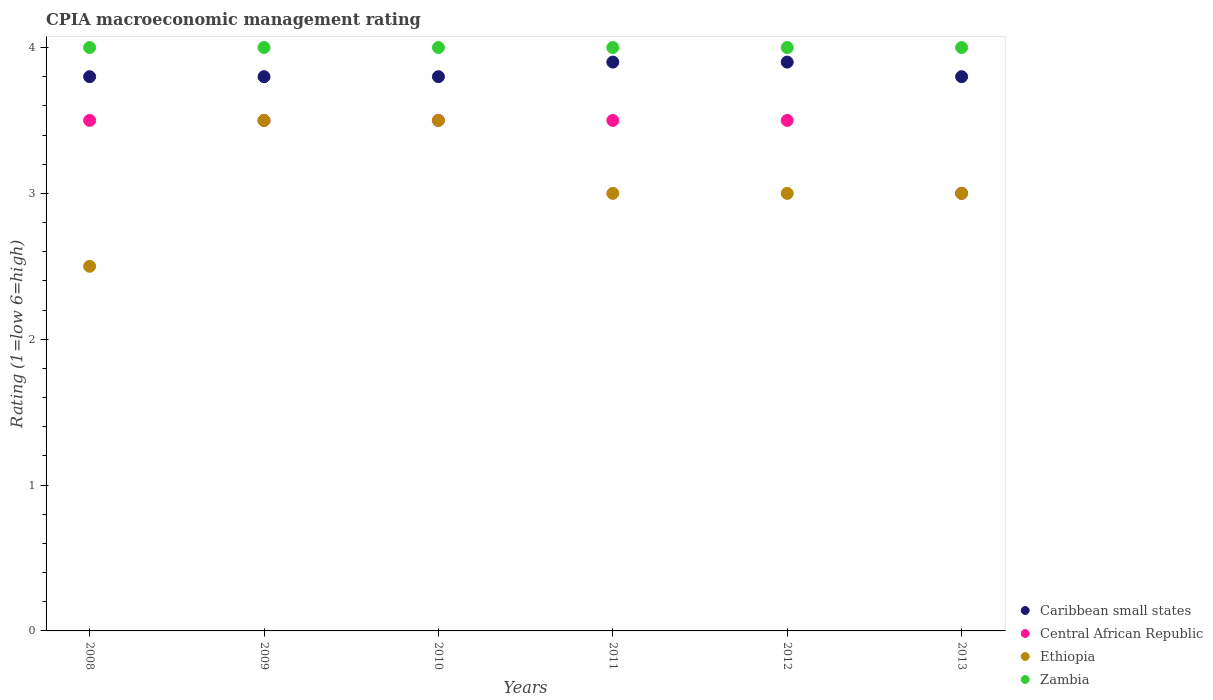How many different coloured dotlines are there?
Your answer should be very brief. 4. What is the CPIA rating in Ethiopia in 2011?
Your answer should be very brief. 3. Across all years, what is the maximum CPIA rating in Zambia?
Your answer should be very brief. 4. In which year was the CPIA rating in Caribbean small states minimum?
Your answer should be very brief. 2008. What is the total CPIA rating in Ethiopia in the graph?
Give a very brief answer. 18.5. What is the difference between the CPIA rating in Ethiopia in 2009 and that in 2010?
Make the answer very short. 0. What is the difference between the CPIA rating in Zambia in 2010 and the CPIA rating in Central African Republic in 2008?
Offer a very short reply. 0.5. What is the average CPIA rating in Central African Republic per year?
Offer a very short reply. 3.42. In the year 2013, what is the difference between the CPIA rating in Zambia and CPIA rating in Caribbean small states?
Offer a very short reply. 0.2. In how many years, is the CPIA rating in Ethiopia greater than 0.4?
Your response must be concise. 6. What is the ratio of the CPIA rating in Caribbean small states in 2011 to that in 2013?
Offer a very short reply. 1.03. Is the CPIA rating in Caribbean small states in 2012 less than that in 2013?
Your response must be concise. No. What is the difference between the highest and the second highest CPIA rating in Ethiopia?
Give a very brief answer. 0. What is the difference between the highest and the lowest CPIA rating in Central African Republic?
Provide a succinct answer. 0.5. In how many years, is the CPIA rating in Central African Republic greater than the average CPIA rating in Central African Republic taken over all years?
Ensure brevity in your answer.  5. Is it the case that in every year, the sum of the CPIA rating in Zambia and CPIA rating in Caribbean small states  is greater than the sum of CPIA rating in Ethiopia and CPIA rating in Central African Republic?
Offer a terse response. Yes. Is it the case that in every year, the sum of the CPIA rating in Ethiopia and CPIA rating in Central African Republic  is greater than the CPIA rating in Zambia?
Make the answer very short. Yes. Does the CPIA rating in Zambia monotonically increase over the years?
Your answer should be compact. No. Is the CPIA rating in Zambia strictly less than the CPIA rating in Central African Republic over the years?
Offer a terse response. No. What is the difference between two consecutive major ticks on the Y-axis?
Offer a very short reply. 1. Does the graph contain grids?
Provide a short and direct response. No. Where does the legend appear in the graph?
Keep it short and to the point. Bottom right. What is the title of the graph?
Make the answer very short. CPIA macroeconomic management rating. What is the Rating (1=low 6=high) in Caribbean small states in 2008?
Ensure brevity in your answer.  3.8. What is the Rating (1=low 6=high) in Caribbean small states in 2009?
Offer a terse response. 3.8. What is the Rating (1=low 6=high) in Central African Republic in 2009?
Keep it short and to the point. 3.5. What is the Rating (1=low 6=high) of Ethiopia in 2009?
Make the answer very short. 3.5. What is the Rating (1=low 6=high) of Central African Republic in 2010?
Provide a succinct answer. 3.5. What is the Rating (1=low 6=high) of Ethiopia in 2010?
Ensure brevity in your answer.  3.5. What is the Rating (1=low 6=high) in Zambia in 2010?
Your answer should be compact. 4. What is the Rating (1=low 6=high) in Central African Republic in 2012?
Your answer should be very brief. 3.5. What is the Rating (1=low 6=high) in Ethiopia in 2012?
Your answer should be compact. 3. What is the Rating (1=low 6=high) of Zambia in 2012?
Keep it short and to the point. 4. What is the Rating (1=low 6=high) in Caribbean small states in 2013?
Your answer should be compact. 3.8. What is the Rating (1=low 6=high) of Central African Republic in 2013?
Offer a very short reply. 3. Across all years, what is the maximum Rating (1=low 6=high) of Caribbean small states?
Your response must be concise. 3.9. Across all years, what is the maximum Rating (1=low 6=high) of Central African Republic?
Your answer should be compact. 3.5. Across all years, what is the maximum Rating (1=low 6=high) in Ethiopia?
Make the answer very short. 3.5. Across all years, what is the maximum Rating (1=low 6=high) in Zambia?
Keep it short and to the point. 4. Across all years, what is the minimum Rating (1=low 6=high) in Central African Republic?
Offer a terse response. 3. Across all years, what is the minimum Rating (1=low 6=high) of Ethiopia?
Ensure brevity in your answer.  2.5. What is the total Rating (1=low 6=high) in Central African Republic in the graph?
Your answer should be compact. 20.5. What is the total Rating (1=low 6=high) of Zambia in the graph?
Give a very brief answer. 24. What is the difference between the Rating (1=low 6=high) in Caribbean small states in 2008 and that in 2011?
Your answer should be very brief. -0.1. What is the difference between the Rating (1=low 6=high) of Central African Republic in 2008 and that in 2011?
Provide a succinct answer. 0. What is the difference between the Rating (1=low 6=high) of Ethiopia in 2008 and that in 2011?
Your answer should be compact. -0.5. What is the difference between the Rating (1=low 6=high) in Zambia in 2008 and that in 2011?
Keep it short and to the point. 0. What is the difference between the Rating (1=low 6=high) in Caribbean small states in 2008 and that in 2012?
Give a very brief answer. -0.1. What is the difference between the Rating (1=low 6=high) of Central African Republic in 2008 and that in 2012?
Your answer should be very brief. 0. What is the difference between the Rating (1=low 6=high) of Ethiopia in 2008 and that in 2012?
Provide a succinct answer. -0.5. What is the difference between the Rating (1=low 6=high) of Zambia in 2008 and that in 2012?
Provide a succinct answer. 0. What is the difference between the Rating (1=low 6=high) of Central African Republic in 2008 and that in 2013?
Provide a succinct answer. 0.5. What is the difference between the Rating (1=low 6=high) of Central African Republic in 2009 and that in 2010?
Provide a short and direct response. 0. What is the difference between the Rating (1=low 6=high) of Ethiopia in 2009 and that in 2010?
Give a very brief answer. 0. What is the difference between the Rating (1=low 6=high) in Central African Republic in 2009 and that in 2011?
Give a very brief answer. 0. What is the difference between the Rating (1=low 6=high) in Ethiopia in 2009 and that in 2011?
Ensure brevity in your answer.  0.5. What is the difference between the Rating (1=low 6=high) in Zambia in 2009 and that in 2011?
Make the answer very short. 0. What is the difference between the Rating (1=low 6=high) of Caribbean small states in 2009 and that in 2012?
Your response must be concise. -0.1. What is the difference between the Rating (1=low 6=high) of Central African Republic in 2009 and that in 2013?
Offer a very short reply. 0.5. What is the difference between the Rating (1=low 6=high) of Ethiopia in 2009 and that in 2013?
Your answer should be compact. 0.5. What is the difference between the Rating (1=low 6=high) of Zambia in 2009 and that in 2013?
Your response must be concise. 0. What is the difference between the Rating (1=low 6=high) in Zambia in 2010 and that in 2011?
Your answer should be compact. 0. What is the difference between the Rating (1=low 6=high) of Ethiopia in 2010 and that in 2012?
Give a very brief answer. 0.5. What is the difference between the Rating (1=low 6=high) of Zambia in 2010 and that in 2012?
Offer a terse response. 0. What is the difference between the Rating (1=low 6=high) of Caribbean small states in 2010 and that in 2013?
Offer a terse response. 0. What is the difference between the Rating (1=low 6=high) in Central African Republic in 2010 and that in 2013?
Your answer should be compact. 0.5. What is the difference between the Rating (1=low 6=high) in Central African Republic in 2011 and that in 2012?
Keep it short and to the point. 0. What is the difference between the Rating (1=low 6=high) of Zambia in 2011 and that in 2012?
Keep it short and to the point. 0. What is the difference between the Rating (1=low 6=high) of Zambia in 2011 and that in 2013?
Offer a very short reply. 0. What is the difference between the Rating (1=low 6=high) in Central African Republic in 2012 and that in 2013?
Offer a very short reply. 0.5. What is the difference between the Rating (1=low 6=high) of Caribbean small states in 2008 and the Rating (1=low 6=high) of Ethiopia in 2009?
Provide a short and direct response. 0.3. What is the difference between the Rating (1=low 6=high) in Central African Republic in 2008 and the Rating (1=low 6=high) in Zambia in 2009?
Provide a short and direct response. -0.5. What is the difference between the Rating (1=low 6=high) in Ethiopia in 2008 and the Rating (1=low 6=high) in Zambia in 2009?
Give a very brief answer. -1.5. What is the difference between the Rating (1=low 6=high) in Ethiopia in 2008 and the Rating (1=low 6=high) in Zambia in 2010?
Your response must be concise. -1.5. What is the difference between the Rating (1=low 6=high) in Caribbean small states in 2008 and the Rating (1=low 6=high) in Ethiopia in 2011?
Offer a very short reply. 0.8. What is the difference between the Rating (1=low 6=high) of Central African Republic in 2008 and the Rating (1=low 6=high) of Ethiopia in 2011?
Provide a short and direct response. 0.5. What is the difference between the Rating (1=low 6=high) of Ethiopia in 2008 and the Rating (1=low 6=high) of Zambia in 2011?
Make the answer very short. -1.5. What is the difference between the Rating (1=low 6=high) in Caribbean small states in 2008 and the Rating (1=low 6=high) in Ethiopia in 2012?
Your response must be concise. 0.8. What is the difference between the Rating (1=low 6=high) in Central African Republic in 2008 and the Rating (1=low 6=high) in Zambia in 2012?
Your answer should be very brief. -0.5. What is the difference between the Rating (1=low 6=high) in Ethiopia in 2008 and the Rating (1=low 6=high) in Zambia in 2012?
Your answer should be compact. -1.5. What is the difference between the Rating (1=low 6=high) of Central African Republic in 2008 and the Rating (1=low 6=high) of Zambia in 2013?
Provide a short and direct response. -0.5. What is the difference between the Rating (1=low 6=high) of Caribbean small states in 2009 and the Rating (1=low 6=high) of Central African Republic in 2010?
Keep it short and to the point. 0.3. What is the difference between the Rating (1=low 6=high) of Caribbean small states in 2009 and the Rating (1=low 6=high) of Ethiopia in 2010?
Provide a short and direct response. 0.3. What is the difference between the Rating (1=low 6=high) in Central African Republic in 2009 and the Rating (1=low 6=high) in Zambia in 2010?
Ensure brevity in your answer.  -0.5. What is the difference between the Rating (1=low 6=high) in Caribbean small states in 2009 and the Rating (1=low 6=high) in Central African Republic in 2011?
Your answer should be compact. 0.3. What is the difference between the Rating (1=low 6=high) of Caribbean small states in 2009 and the Rating (1=low 6=high) of Ethiopia in 2011?
Your response must be concise. 0.8. What is the difference between the Rating (1=low 6=high) in Caribbean small states in 2009 and the Rating (1=low 6=high) in Zambia in 2011?
Your response must be concise. -0.2. What is the difference between the Rating (1=low 6=high) in Central African Republic in 2009 and the Rating (1=low 6=high) in Ethiopia in 2011?
Provide a succinct answer. 0.5. What is the difference between the Rating (1=low 6=high) of Ethiopia in 2009 and the Rating (1=low 6=high) of Zambia in 2011?
Give a very brief answer. -0.5. What is the difference between the Rating (1=low 6=high) in Caribbean small states in 2009 and the Rating (1=low 6=high) in Central African Republic in 2012?
Your response must be concise. 0.3. What is the difference between the Rating (1=low 6=high) in Caribbean small states in 2009 and the Rating (1=low 6=high) in Zambia in 2012?
Offer a terse response. -0.2. What is the difference between the Rating (1=low 6=high) in Central African Republic in 2009 and the Rating (1=low 6=high) in Zambia in 2012?
Keep it short and to the point. -0.5. What is the difference between the Rating (1=low 6=high) of Ethiopia in 2009 and the Rating (1=low 6=high) of Zambia in 2012?
Keep it short and to the point. -0.5. What is the difference between the Rating (1=low 6=high) in Caribbean small states in 2009 and the Rating (1=low 6=high) in Ethiopia in 2013?
Provide a succinct answer. 0.8. What is the difference between the Rating (1=low 6=high) in Caribbean small states in 2009 and the Rating (1=low 6=high) in Zambia in 2013?
Provide a short and direct response. -0.2. What is the difference between the Rating (1=low 6=high) in Central African Republic in 2009 and the Rating (1=low 6=high) in Ethiopia in 2013?
Your response must be concise. 0.5. What is the difference between the Rating (1=low 6=high) of Central African Republic in 2009 and the Rating (1=low 6=high) of Zambia in 2013?
Provide a succinct answer. -0.5. What is the difference between the Rating (1=low 6=high) in Caribbean small states in 2010 and the Rating (1=low 6=high) in Central African Republic in 2011?
Give a very brief answer. 0.3. What is the difference between the Rating (1=low 6=high) of Central African Republic in 2010 and the Rating (1=low 6=high) of Ethiopia in 2011?
Make the answer very short. 0.5. What is the difference between the Rating (1=low 6=high) of Central African Republic in 2010 and the Rating (1=low 6=high) of Zambia in 2011?
Your answer should be very brief. -0.5. What is the difference between the Rating (1=low 6=high) in Ethiopia in 2010 and the Rating (1=low 6=high) in Zambia in 2011?
Provide a succinct answer. -0.5. What is the difference between the Rating (1=low 6=high) in Caribbean small states in 2010 and the Rating (1=low 6=high) in Zambia in 2012?
Provide a succinct answer. -0.2. What is the difference between the Rating (1=low 6=high) in Central African Republic in 2010 and the Rating (1=low 6=high) in Ethiopia in 2012?
Ensure brevity in your answer.  0.5. What is the difference between the Rating (1=low 6=high) in Central African Republic in 2010 and the Rating (1=low 6=high) in Zambia in 2012?
Offer a very short reply. -0.5. What is the difference between the Rating (1=low 6=high) in Ethiopia in 2010 and the Rating (1=low 6=high) in Zambia in 2012?
Provide a short and direct response. -0.5. What is the difference between the Rating (1=low 6=high) of Caribbean small states in 2010 and the Rating (1=low 6=high) of Central African Republic in 2013?
Provide a short and direct response. 0.8. What is the difference between the Rating (1=low 6=high) in Central African Republic in 2010 and the Rating (1=low 6=high) in Zambia in 2013?
Your answer should be compact. -0.5. What is the difference between the Rating (1=low 6=high) in Ethiopia in 2010 and the Rating (1=low 6=high) in Zambia in 2013?
Offer a very short reply. -0.5. What is the difference between the Rating (1=low 6=high) of Caribbean small states in 2011 and the Rating (1=low 6=high) of Central African Republic in 2012?
Offer a terse response. 0.4. What is the difference between the Rating (1=low 6=high) in Caribbean small states in 2011 and the Rating (1=low 6=high) in Ethiopia in 2012?
Your answer should be compact. 0.9. What is the difference between the Rating (1=low 6=high) of Caribbean small states in 2011 and the Rating (1=low 6=high) of Zambia in 2012?
Provide a succinct answer. -0.1. What is the difference between the Rating (1=low 6=high) in Central African Republic in 2011 and the Rating (1=low 6=high) in Ethiopia in 2012?
Keep it short and to the point. 0.5. What is the difference between the Rating (1=low 6=high) in Central African Republic in 2011 and the Rating (1=low 6=high) in Zambia in 2012?
Provide a succinct answer. -0.5. What is the difference between the Rating (1=low 6=high) in Ethiopia in 2011 and the Rating (1=low 6=high) in Zambia in 2012?
Your answer should be very brief. -1. What is the difference between the Rating (1=low 6=high) of Caribbean small states in 2011 and the Rating (1=low 6=high) of Ethiopia in 2013?
Your answer should be compact. 0.9. What is the difference between the Rating (1=low 6=high) of Caribbean small states in 2011 and the Rating (1=low 6=high) of Zambia in 2013?
Keep it short and to the point. -0.1. What is the difference between the Rating (1=low 6=high) in Central African Republic in 2011 and the Rating (1=low 6=high) in Ethiopia in 2013?
Ensure brevity in your answer.  0.5. What is the difference between the Rating (1=low 6=high) in Central African Republic in 2011 and the Rating (1=low 6=high) in Zambia in 2013?
Your response must be concise. -0.5. What is the difference between the Rating (1=low 6=high) in Ethiopia in 2011 and the Rating (1=low 6=high) in Zambia in 2013?
Ensure brevity in your answer.  -1. What is the difference between the Rating (1=low 6=high) in Caribbean small states in 2012 and the Rating (1=low 6=high) in Central African Republic in 2013?
Your answer should be compact. 0.9. What is the difference between the Rating (1=low 6=high) of Caribbean small states in 2012 and the Rating (1=low 6=high) of Ethiopia in 2013?
Your response must be concise. 0.9. What is the difference between the Rating (1=low 6=high) in Caribbean small states in 2012 and the Rating (1=low 6=high) in Zambia in 2013?
Give a very brief answer. -0.1. What is the difference between the Rating (1=low 6=high) of Central African Republic in 2012 and the Rating (1=low 6=high) of Ethiopia in 2013?
Give a very brief answer. 0.5. What is the difference between the Rating (1=low 6=high) of Central African Republic in 2012 and the Rating (1=low 6=high) of Zambia in 2013?
Provide a short and direct response. -0.5. What is the average Rating (1=low 6=high) of Caribbean small states per year?
Keep it short and to the point. 3.83. What is the average Rating (1=low 6=high) of Central African Republic per year?
Your answer should be compact. 3.42. What is the average Rating (1=low 6=high) in Ethiopia per year?
Provide a succinct answer. 3.08. What is the average Rating (1=low 6=high) in Zambia per year?
Your answer should be very brief. 4. In the year 2008, what is the difference between the Rating (1=low 6=high) of Caribbean small states and Rating (1=low 6=high) of Central African Republic?
Provide a short and direct response. 0.3. In the year 2008, what is the difference between the Rating (1=low 6=high) of Caribbean small states and Rating (1=low 6=high) of Zambia?
Your answer should be compact. -0.2. In the year 2009, what is the difference between the Rating (1=low 6=high) of Central African Republic and Rating (1=low 6=high) of Ethiopia?
Your answer should be very brief. 0. In the year 2009, what is the difference between the Rating (1=low 6=high) of Central African Republic and Rating (1=low 6=high) of Zambia?
Offer a very short reply. -0.5. In the year 2010, what is the difference between the Rating (1=low 6=high) in Caribbean small states and Rating (1=low 6=high) in Central African Republic?
Offer a terse response. 0.3. In the year 2010, what is the difference between the Rating (1=low 6=high) of Central African Republic and Rating (1=low 6=high) of Zambia?
Make the answer very short. -0.5. In the year 2011, what is the difference between the Rating (1=low 6=high) of Caribbean small states and Rating (1=low 6=high) of Central African Republic?
Provide a short and direct response. 0.4. In the year 2011, what is the difference between the Rating (1=low 6=high) of Central African Republic and Rating (1=low 6=high) of Zambia?
Give a very brief answer. -0.5. In the year 2012, what is the difference between the Rating (1=low 6=high) of Caribbean small states and Rating (1=low 6=high) of Ethiopia?
Keep it short and to the point. 0.9. In the year 2012, what is the difference between the Rating (1=low 6=high) in Central African Republic and Rating (1=low 6=high) in Ethiopia?
Provide a short and direct response. 0.5. In the year 2012, what is the difference between the Rating (1=low 6=high) in Central African Republic and Rating (1=low 6=high) in Zambia?
Make the answer very short. -0.5. In the year 2012, what is the difference between the Rating (1=low 6=high) of Ethiopia and Rating (1=low 6=high) of Zambia?
Make the answer very short. -1. In the year 2013, what is the difference between the Rating (1=low 6=high) of Ethiopia and Rating (1=low 6=high) of Zambia?
Keep it short and to the point. -1. What is the ratio of the Rating (1=low 6=high) in Caribbean small states in 2008 to that in 2009?
Make the answer very short. 1. What is the ratio of the Rating (1=low 6=high) of Zambia in 2008 to that in 2009?
Your answer should be compact. 1. What is the ratio of the Rating (1=low 6=high) of Caribbean small states in 2008 to that in 2010?
Your answer should be very brief. 1. What is the ratio of the Rating (1=low 6=high) of Central African Republic in 2008 to that in 2010?
Your response must be concise. 1. What is the ratio of the Rating (1=low 6=high) in Zambia in 2008 to that in 2010?
Your answer should be compact. 1. What is the ratio of the Rating (1=low 6=high) of Caribbean small states in 2008 to that in 2011?
Your response must be concise. 0.97. What is the ratio of the Rating (1=low 6=high) in Central African Republic in 2008 to that in 2011?
Provide a succinct answer. 1. What is the ratio of the Rating (1=low 6=high) of Caribbean small states in 2008 to that in 2012?
Offer a terse response. 0.97. What is the ratio of the Rating (1=low 6=high) of Central African Republic in 2008 to that in 2012?
Your answer should be very brief. 1. What is the ratio of the Rating (1=low 6=high) of Ethiopia in 2008 to that in 2012?
Your response must be concise. 0.83. What is the ratio of the Rating (1=low 6=high) in Central African Republic in 2008 to that in 2013?
Keep it short and to the point. 1.17. What is the ratio of the Rating (1=low 6=high) of Zambia in 2008 to that in 2013?
Offer a terse response. 1. What is the ratio of the Rating (1=low 6=high) in Ethiopia in 2009 to that in 2010?
Offer a very short reply. 1. What is the ratio of the Rating (1=low 6=high) of Caribbean small states in 2009 to that in 2011?
Provide a short and direct response. 0.97. What is the ratio of the Rating (1=low 6=high) of Zambia in 2009 to that in 2011?
Provide a succinct answer. 1. What is the ratio of the Rating (1=low 6=high) of Caribbean small states in 2009 to that in 2012?
Offer a very short reply. 0.97. What is the ratio of the Rating (1=low 6=high) of Central African Republic in 2009 to that in 2012?
Offer a very short reply. 1. What is the ratio of the Rating (1=low 6=high) in Ethiopia in 2009 to that in 2012?
Your answer should be compact. 1.17. What is the ratio of the Rating (1=low 6=high) in Central African Republic in 2009 to that in 2013?
Give a very brief answer. 1.17. What is the ratio of the Rating (1=low 6=high) in Ethiopia in 2009 to that in 2013?
Keep it short and to the point. 1.17. What is the ratio of the Rating (1=low 6=high) of Caribbean small states in 2010 to that in 2011?
Ensure brevity in your answer.  0.97. What is the ratio of the Rating (1=low 6=high) of Central African Republic in 2010 to that in 2011?
Offer a very short reply. 1. What is the ratio of the Rating (1=low 6=high) of Caribbean small states in 2010 to that in 2012?
Ensure brevity in your answer.  0.97. What is the ratio of the Rating (1=low 6=high) of Zambia in 2010 to that in 2012?
Provide a succinct answer. 1. What is the ratio of the Rating (1=low 6=high) in Central African Republic in 2010 to that in 2013?
Ensure brevity in your answer.  1.17. What is the ratio of the Rating (1=low 6=high) of Caribbean small states in 2011 to that in 2012?
Ensure brevity in your answer.  1. What is the ratio of the Rating (1=low 6=high) in Central African Republic in 2011 to that in 2012?
Make the answer very short. 1. What is the ratio of the Rating (1=low 6=high) in Ethiopia in 2011 to that in 2012?
Your response must be concise. 1. What is the ratio of the Rating (1=low 6=high) of Zambia in 2011 to that in 2012?
Your response must be concise. 1. What is the ratio of the Rating (1=low 6=high) in Caribbean small states in 2011 to that in 2013?
Offer a very short reply. 1.03. What is the ratio of the Rating (1=low 6=high) of Central African Republic in 2011 to that in 2013?
Your response must be concise. 1.17. What is the ratio of the Rating (1=low 6=high) in Ethiopia in 2011 to that in 2013?
Provide a succinct answer. 1. What is the ratio of the Rating (1=low 6=high) of Caribbean small states in 2012 to that in 2013?
Your answer should be compact. 1.03. What is the ratio of the Rating (1=low 6=high) of Ethiopia in 2012 to that in 2013?
Keep it short and to the point. 1. What is the difference between the highest and the second highest Rating (1=low 6=high) in Ethiopia?
Offer a very short reply. 0. What is the difference between the highest and the lowest Rating (1=low 6=high) in Central African Republic?
Provide a succinct answer. 0.5. What is the difference between the highest and the lowest Rating (1=low 6=high) in Ethiopia?
Your answer should be very brief. 1. 